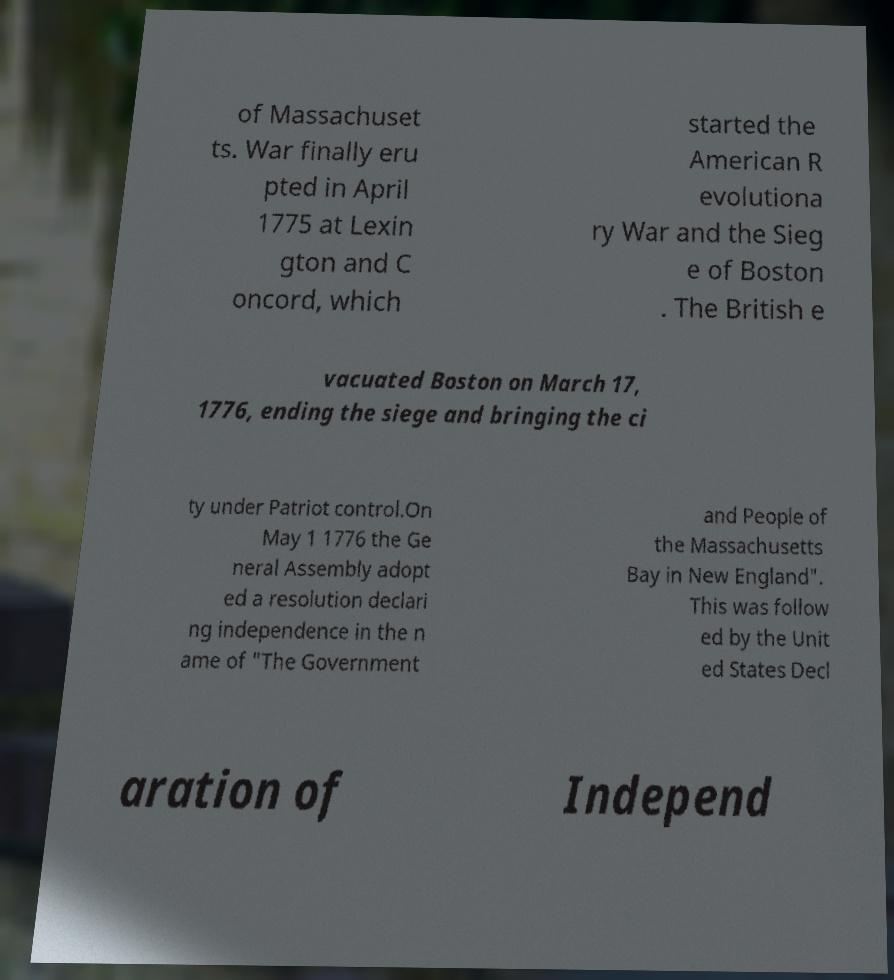Can you accurately transcribe the text from the provided image for me? of Massachuset ts. War finally eru pted in April 1775 at Lexin gton and C oncord, which started the American R evolutiona ry War and the Sieg e of Boston . The British e vacuated Boston on March 17, 1776, ending the siege and bringing the ci ty under Patriot control.On May 1 1776 the Ge neral Assembly adopt ed a resolution declari ng independence in the n ame of "The Government and People of the Massachusetts Bay in New England". This was follow ed by the Unit ed States Decl aration of Independ 